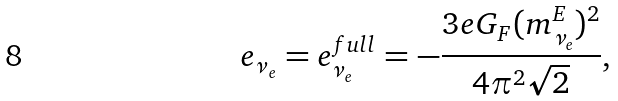Convert formula to latex. <formula><loc_0><loc_0><loc_500><loc_500>e _ { \nu _ { e } } = e _ { \nu _ { e } } ^ { f u l l } = - \frac { 3 e G _ { F } ( m _ { \nu _ { e } } ^ { E } ) ^ { 2 } } { 4 \pi ^ { 2 } \sqrt { 2 } } ,</formula> 